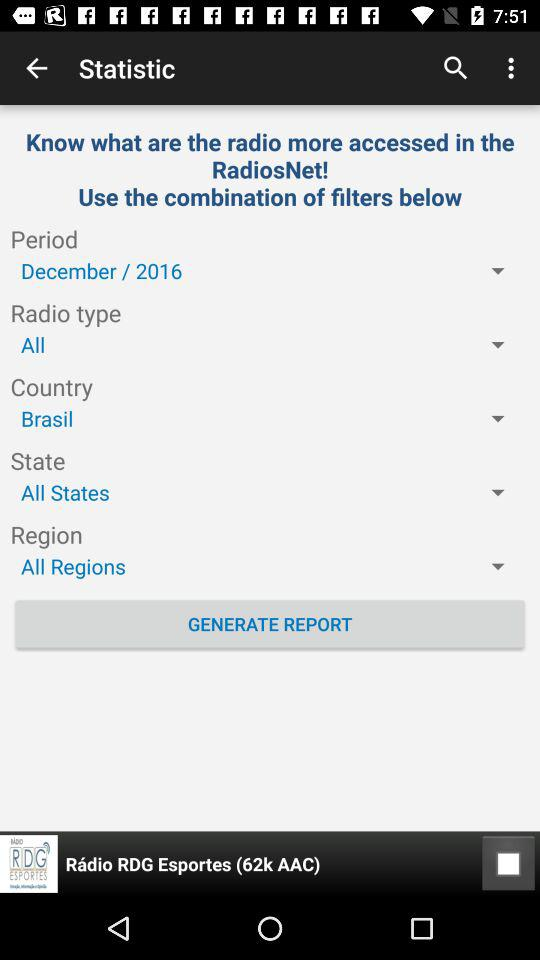What is the number in the radio rdg esportes?
When the provided information is insufficient, respond with <no answer>. <no answer> 